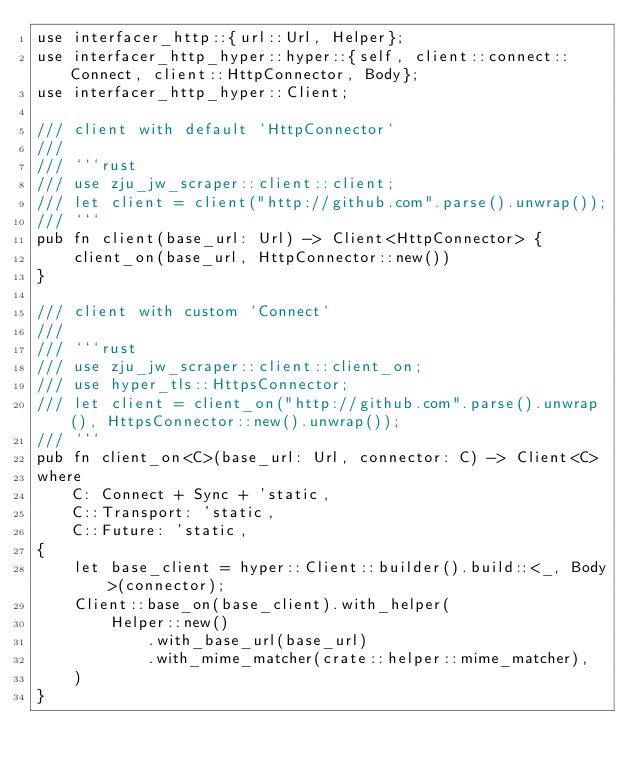Convert code to text. <code><loc_0><loc_0><loc_500><loc_500><_Rust_>use interfacer_http::{url::Url, Helper};
use interfacer_http_hyper::hyper::{self, client::connect::Connect, client::HttpConnector, Body};
use interfacer_http_hyper::Client;

/// client with default `HttpConnector`
///
/// ```rust
/// use zju_jw_scraper::client::client;
/// let client = client("http://github.com".parse().unwrap());
/// ```
pub fn client(base_url: Url) -> Client<HttpConnector> {
    client_on(base_url, HttpConnector::new())
}

/// client with custom `Connect`
///
/// ```rust
/// use zju_jw_scraper::client::client_on;
/// use hyper_tls::HttpsConnector;
/// let client = client_on("http://github.com".parse().unwrap(), HttpsConnector::new().unwrap());
/// ```
pub fn client_on<C>(base_url: Url, connector: C) -> Client<C>
where
    C: Connect + Sync + 'static,
    C::Transport: 'static,
    C::Future: 'static,
{
    let base_client = hyper::Client::builder().build::<_, Body>(connector);
    Client::base_on(base_client).with_helper(
        Helper::new()
            .with_base_url(base_url)
            .with_mime_matcher(crate::helper::mime_matcher),
    )
}
</code> 